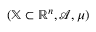<formula> <loc_0><loc_0><loc_500><loc_500>( \mathbb { X } \subset \mathbb { R } ^ { n } , \mathcal { A } , \mu )</formula> 